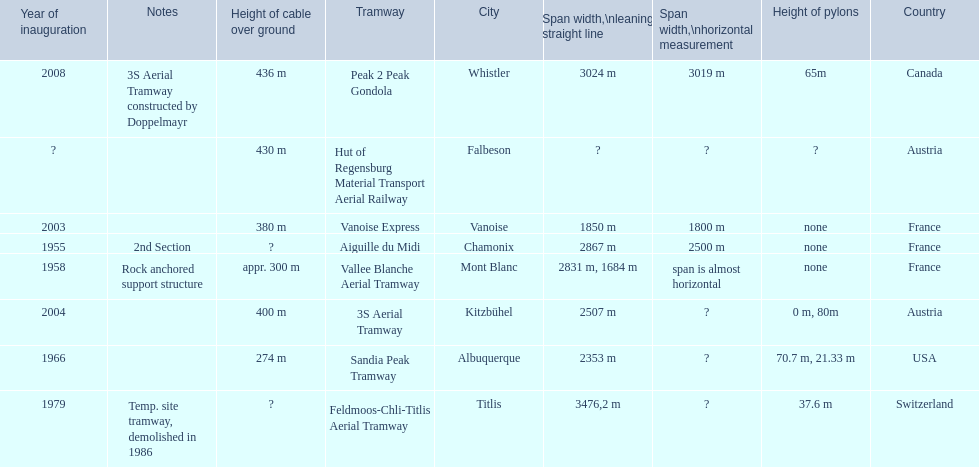When was the aiguille du midi tramway inaugurated? 1955. When was the 3s aerial tramway inaugurated? 2004. Which one was inaugurated first? Aiguille du Midi. 